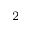<formula> <loc_0><loc_0><loc_500><loc_500>^ { 2 }</formula> 